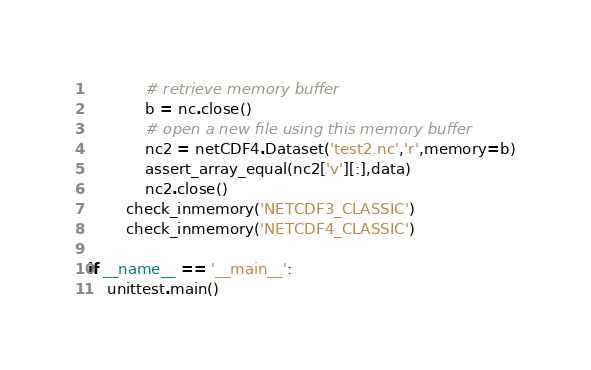<code> <loc_0><loc_0><loc_500><loc_500><_Python_>            # retrieve memory buffer
            b = nc.close()
            # open a new file using this memory buffer
            nc2 = netCDF4.Dataset('test2.nc','r',memory=b)
            assert_array_equal(nc2['v'][:],data)
            nc2.close()
        check_inmemory('NETCDF3_CLASSIC')
        check_inmemory('NETCDF4_CLASSIC')

if __name__ == '__main__':
    unittest.main()
</code> 